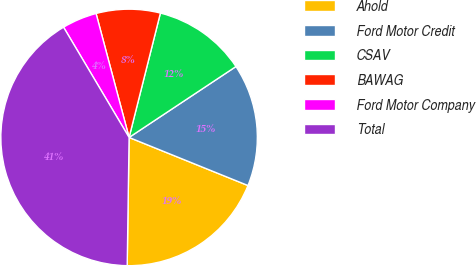Convert chart to OTSL. <chart><loc_0><loc_0><loc_500><loc_500><pie_chart><fcel>Ahold<fcel>Ford Motor Credit<fcel>CSAV<fcel>BAWAG<fcel>Ford Motor Company<fcel>Total<nl><fcel>19.12%<fcel>15.44%<fcel>11.75%<fcel>8.07%<fcel>4.39%<fcel>41.23%<nl></chart> 